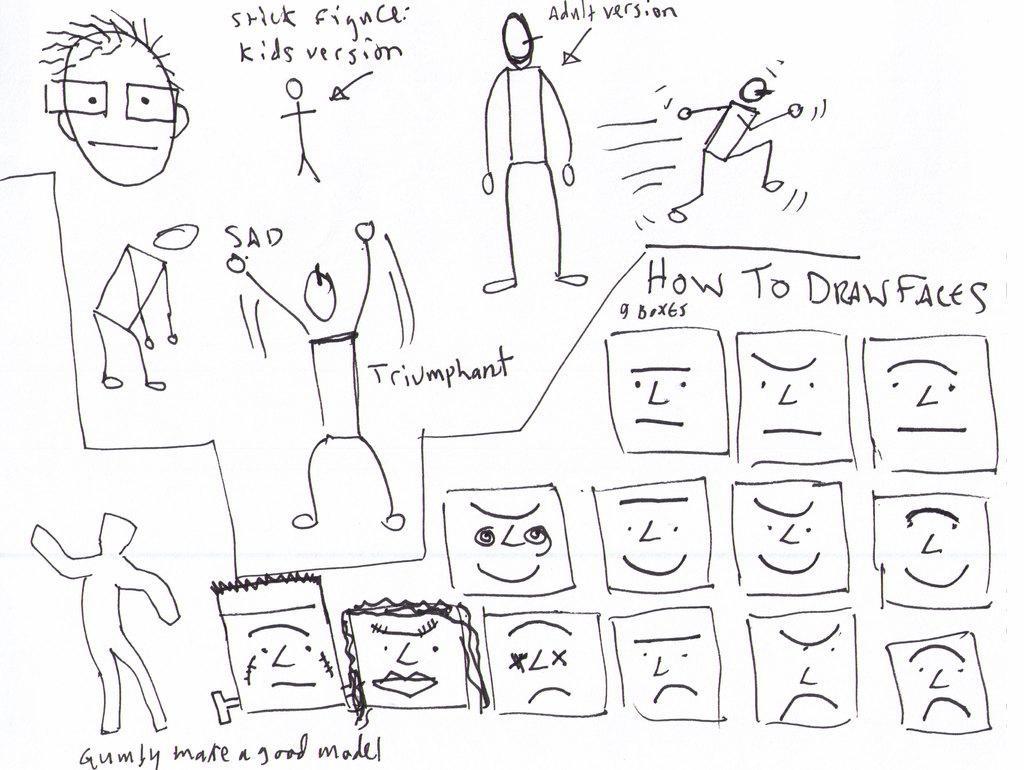What is the main subject of the image? There is a drawing in the image. Can you describe the drawing? The drawing has writing on it. What type of bomb is depicted in the drawing? There is no bomb depicted in the drawing; it only contains writing. How many toads are present in the image? There are no toads present in the image; it only features a drawing with writing. 